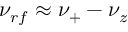Convert formula to latex. <formula><loc_0><loc_0><loc_500><loc_500>\nu _ { r f } \approx \nu _ { + } - \nu _ { z }</formula> 